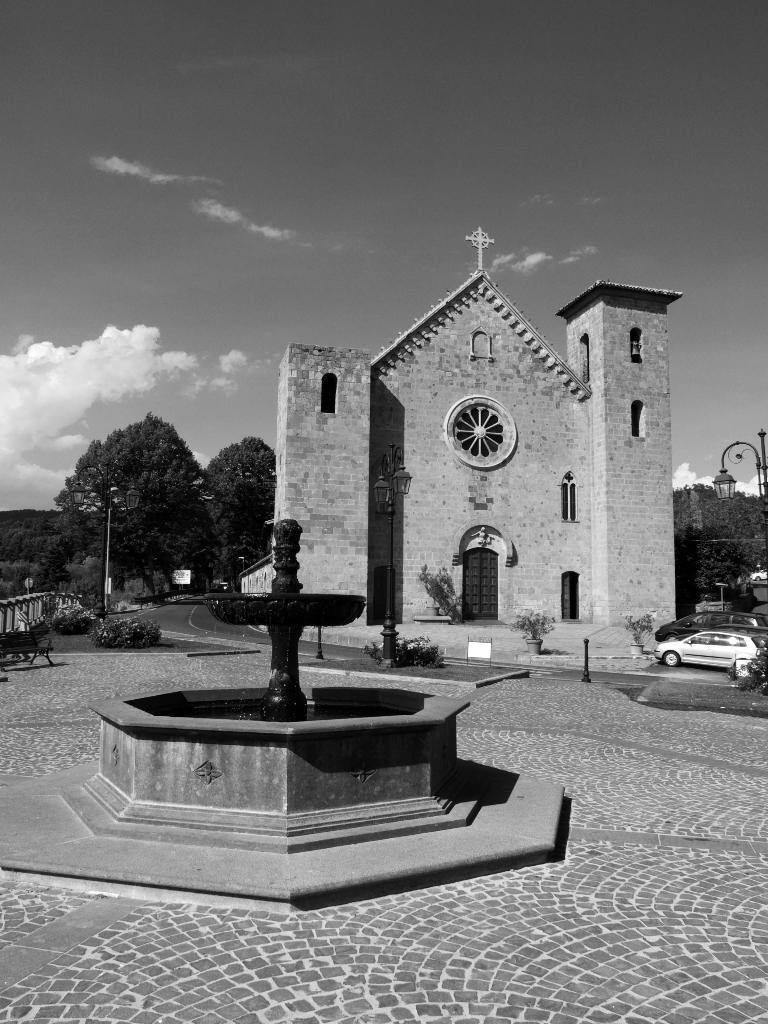Please provide a concise description of this image. This is an outside view and it is a black and white image. On the left side there is a fountain. In the background there is a building. On the left side there are few vehicles on the road and also there is a light pole. In the background there are trees. At the top of the image I can see the sky and clouds. 